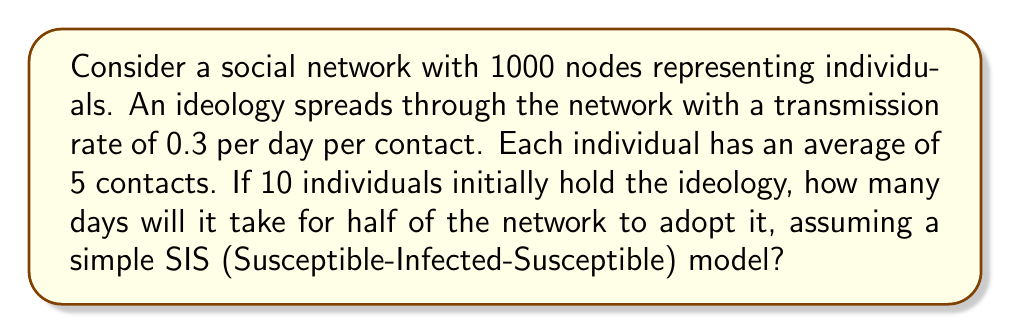Can you solve this math problem? To solve this problem, we'll use the SIS model and the concept of the basic reproduction number $R_0$.

1) In the SIS model, the rate of change of infected individuals is given by:

   $$\frac{dI}{dt} = \beta SI - \gamma I$$

   Where $I$ is the number of infected (ideology adopters), $S$ is the number of susceptible, $\beta$ is the transmission rate per contact, and $\gamma$ is the recovery rate.

2) The basic reproduction number $R_0$ is given by:

   $$R_0 = \frac{\beta N}{\gamma}$$

   Where $N$ is the average number of contacts.

3) In this case, $\beta = 0.3$, $N = 5$, and we assume $\gamma = 0$ (no recovery in ideology adoption).

   $$R_0 = 0.3 * 5 = 1.5$$

4) The time $t$ for the number of infected to reach a fraction $f$ of the population is approximated by:

   $$t \approx \frac{\ln(f(R_0-1)+1)}{(R_0-1)\gamma + \ln(R_0)/N}$$

5) We want $f = 0.5$ (half the network). Substituting our values:

   $$t \approx \frac{\ln(0.5(1.5-1)+1)}{(1.5-1)*0 + \ln(1.5)/1000}$$

6) Simplifying:

   $$t \approx \frac{\ln(1.25)}{\ln(1.5)/1000} \approx 16.06$$

Therefore, it will take approximately 16 days for half of the network to adopt the ideology.
Answer: 16 days 